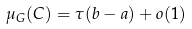Convert formula to latex. <formula><loc_0><loc_0><loc_500><loc_500>\mu _ { G } ( C ) = \tau ( b - a ) + o ( 1 )</formula> 